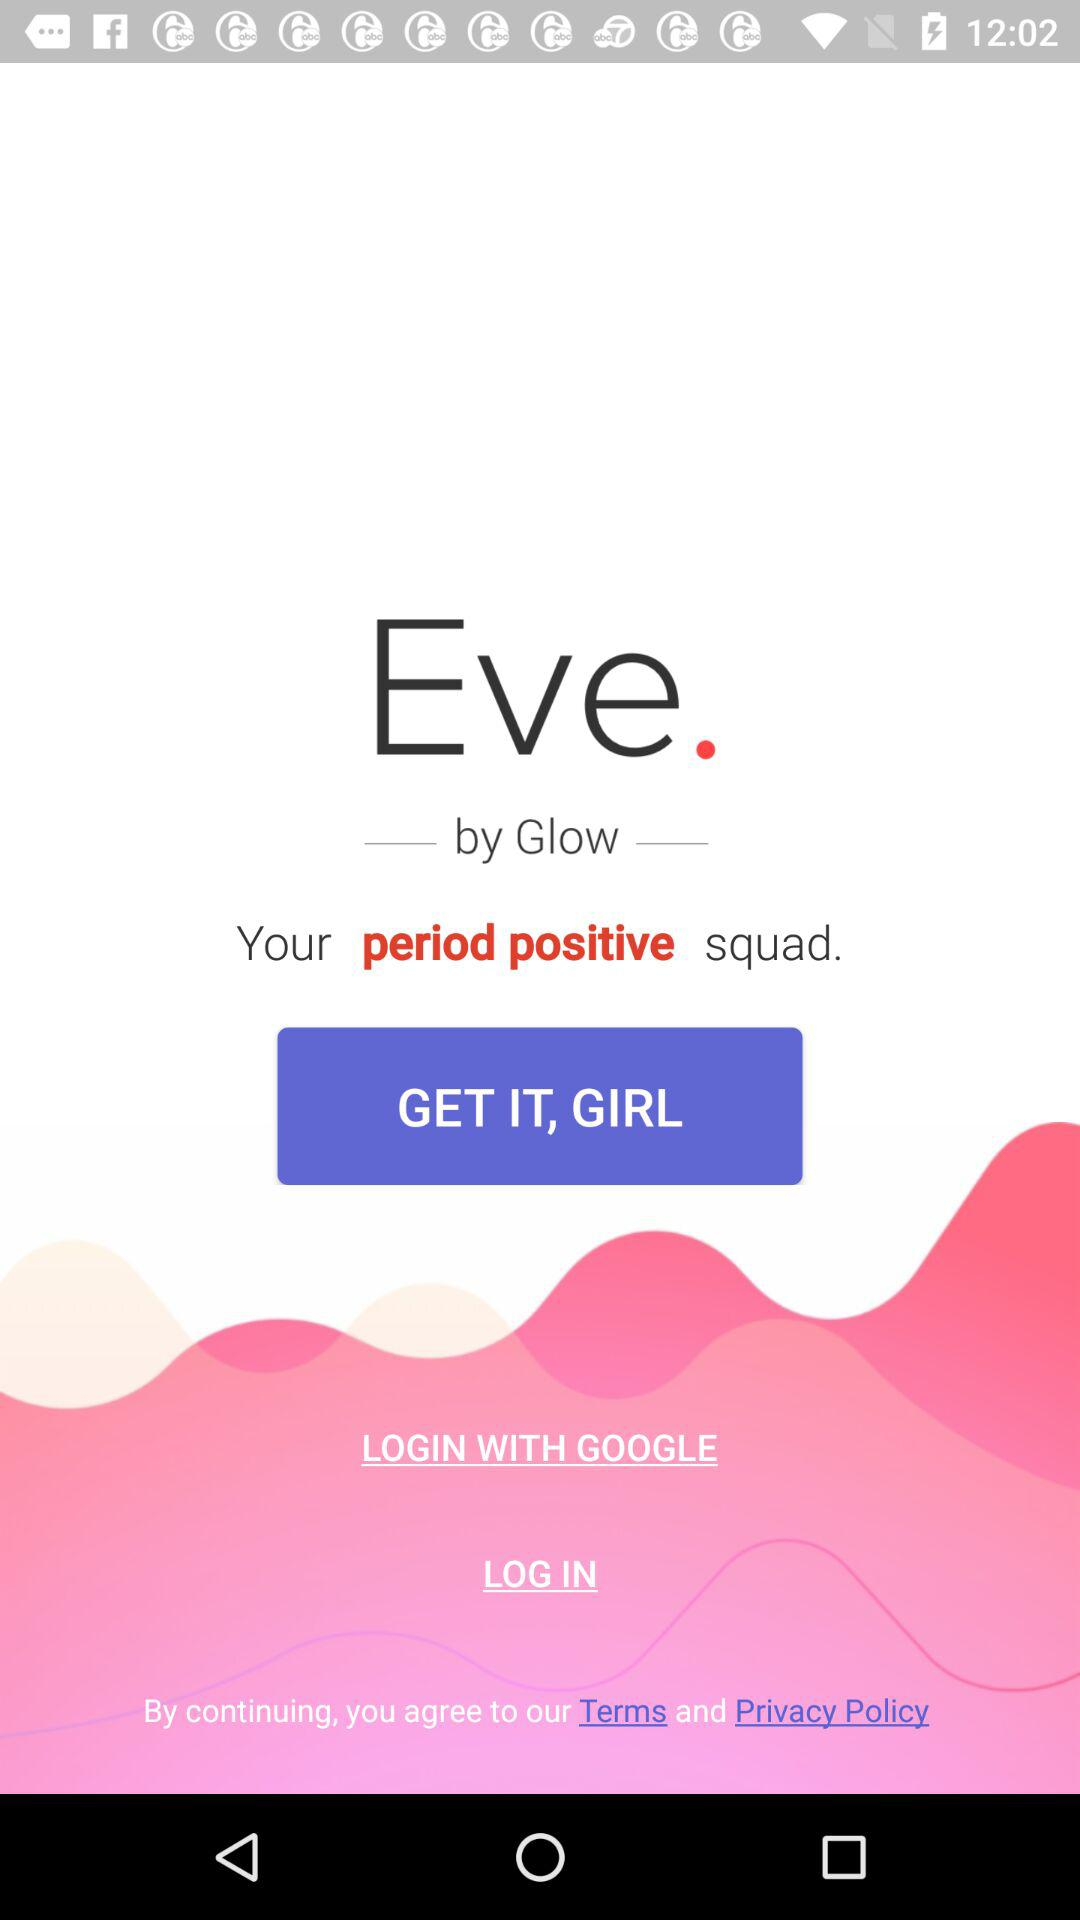What is the name of the application? The name of the application is "Eve". 